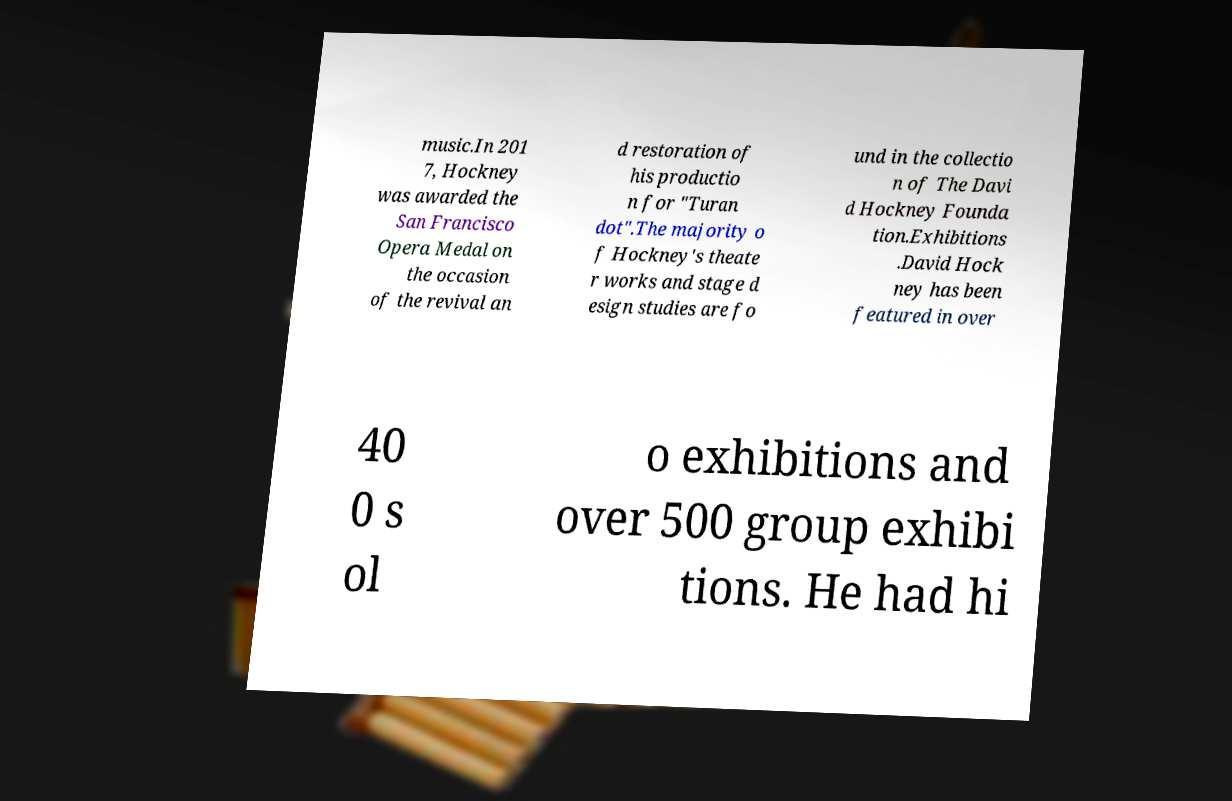Please identify and transcribe the text found in this image. music.In 201 7, Hockney was awarded the San Francisco Opera Medal on the occasion of the revival an d restoration of his productio n for "Turan dot".The majority o f Hockney's theate r works and stage d esign studies are fo und in the collectio n of The Davi d Hockney Founda tion.Exhibitions .David Hock ney has been featured in over 40 0 s ol o exhibitions and over 500 group exhibi tions. He had hi 